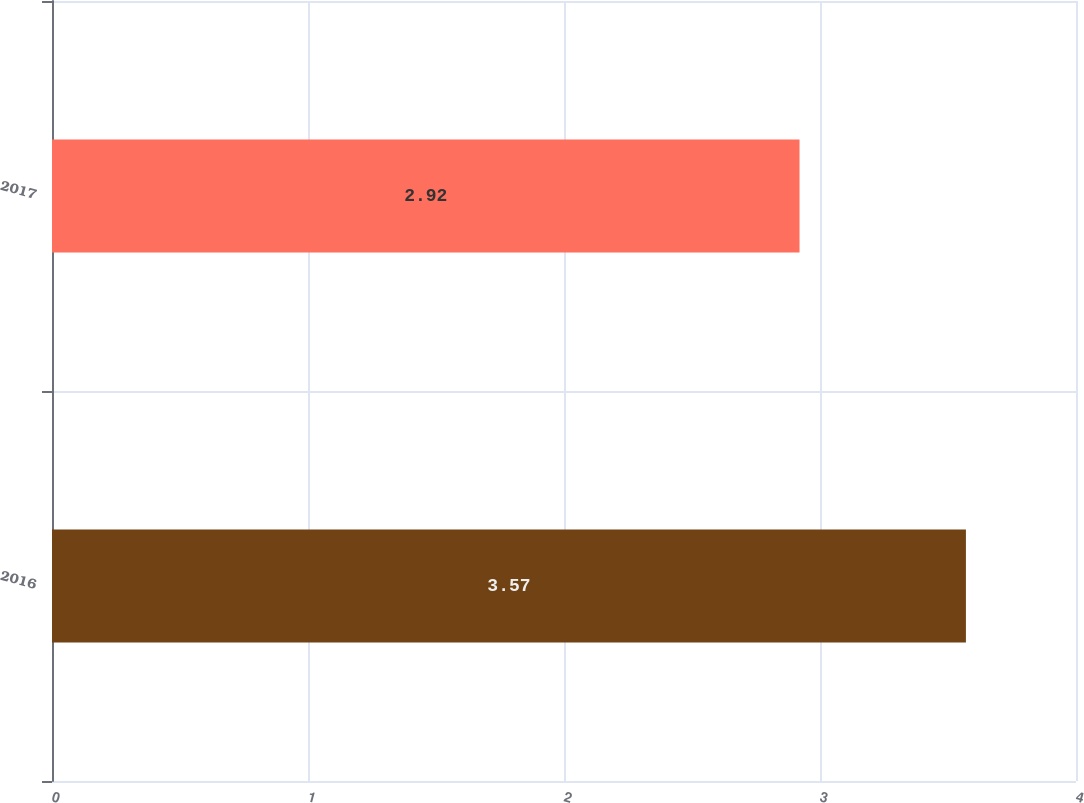Convert chart to OTSL. <chart><loc_0><loc_0><loc_500><loc_500><bar_chart><fcel>2016<fcel>2017<nl><fcel>3.57<fcel>2.92<nl></chart> 